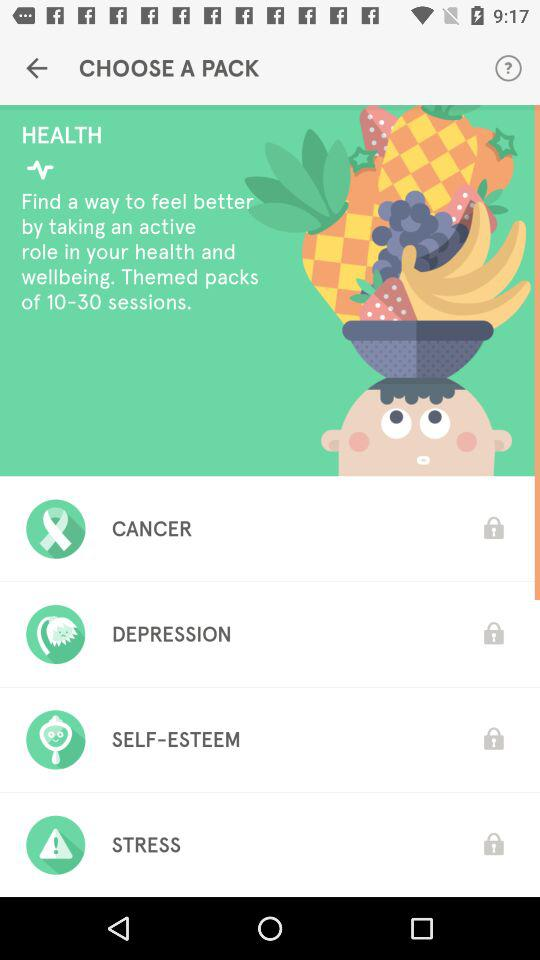How many packs are there in total?
Answer the question using a single word or phrase. 4 